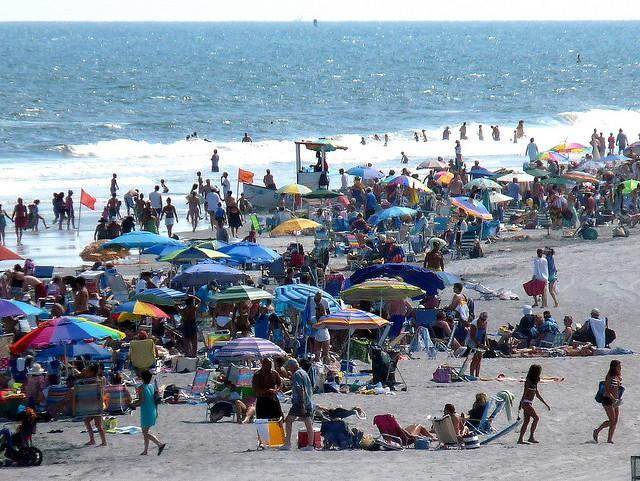What is the person in the elevated stand watching? Please explain your reasoning. swimmers. They are a lifeguard. 